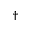<formula> <loc_0><loc_0><loc_500><loc_500>^ { \dag }</formula> 